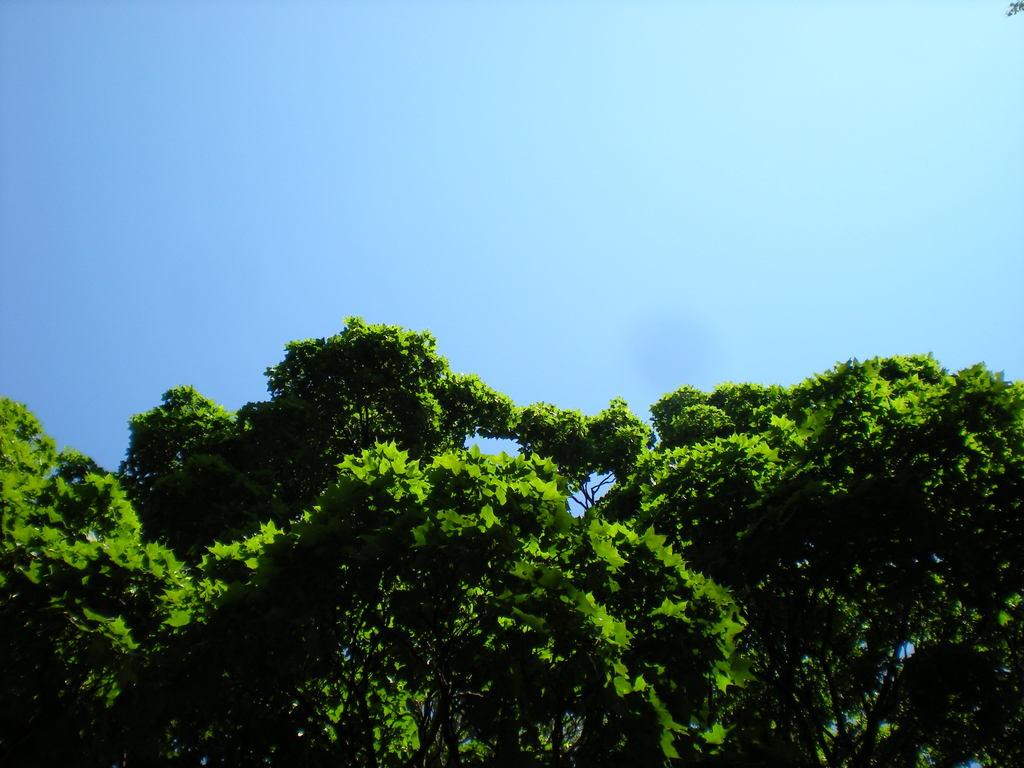What type of vegetation is visible in the front of the image? There are trees in the front of the image. What can be seen in the background of the image? The background of the image includes the sky. What color is the root of the tree in the image? There is no root visible in the image, as only the trees' trunks and branches are shown. 